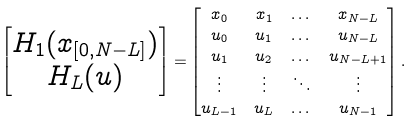<formula> <loc_0><loc_0><loc_500><loc_500>\begin{bmatrix} H _ { 1 } ( x _ { [ 0 , N - L ] } ) \\ H _ { L } ( u ) \end{bmatrix} = & \begin{bmatrix} x _ { 0 } & x _ { 1 } & \dots & x _ { N - L } \\ u _ { 0 } & u _ { 1 } & \dots & u _ { N - L } \\ u _ { 1 } & u _ { 2 } & \dots & u _ { N - L + 1 } \\ \vdots & \vdots & \ddots & \vdots \\ u _ { L - 1 } & u _ { L } & \dots & u _ { N - 1 } \end{bmatrix} .</formula> 